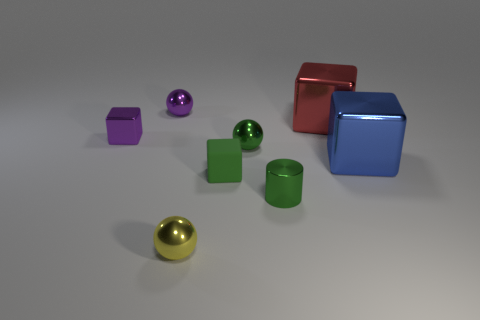Is there any other thing that has the same material as the small green block?
Offer a very short reply. No. What number of small cyan things are there?
Your answer should be compact. 0. Is there a small blue object that has the same material as the cylinder?
Your answer should be very brief. No. There is a sphere that is the same color as the tiny rubber object; what is its size?
Provide a short and direct response. Small. Do the shiny ball in front of the metal cylinder and the green thing in front of the small green rubber thing have the same size?
Offer a very short reply. Yes. There is a green shiny thing behind the blue block; what is its size?
Give a very brief answer. Small. Is there a shiny cylinder of the same color as the matte thing?
Your answer should be compact. Yes. Are there any tiny objects that are behind the green shiny thing that is in front of the big blue object?
Provide a short and direct response. Yes. There is a green rubber cube; is it the same size as the ball in front of the tiny green ball?
Make the answer very short. Yes. Is there a purple metallic object behind the green metal object in front of the green thing behind the large blue block?
Keep it short and to the point. Yes. 